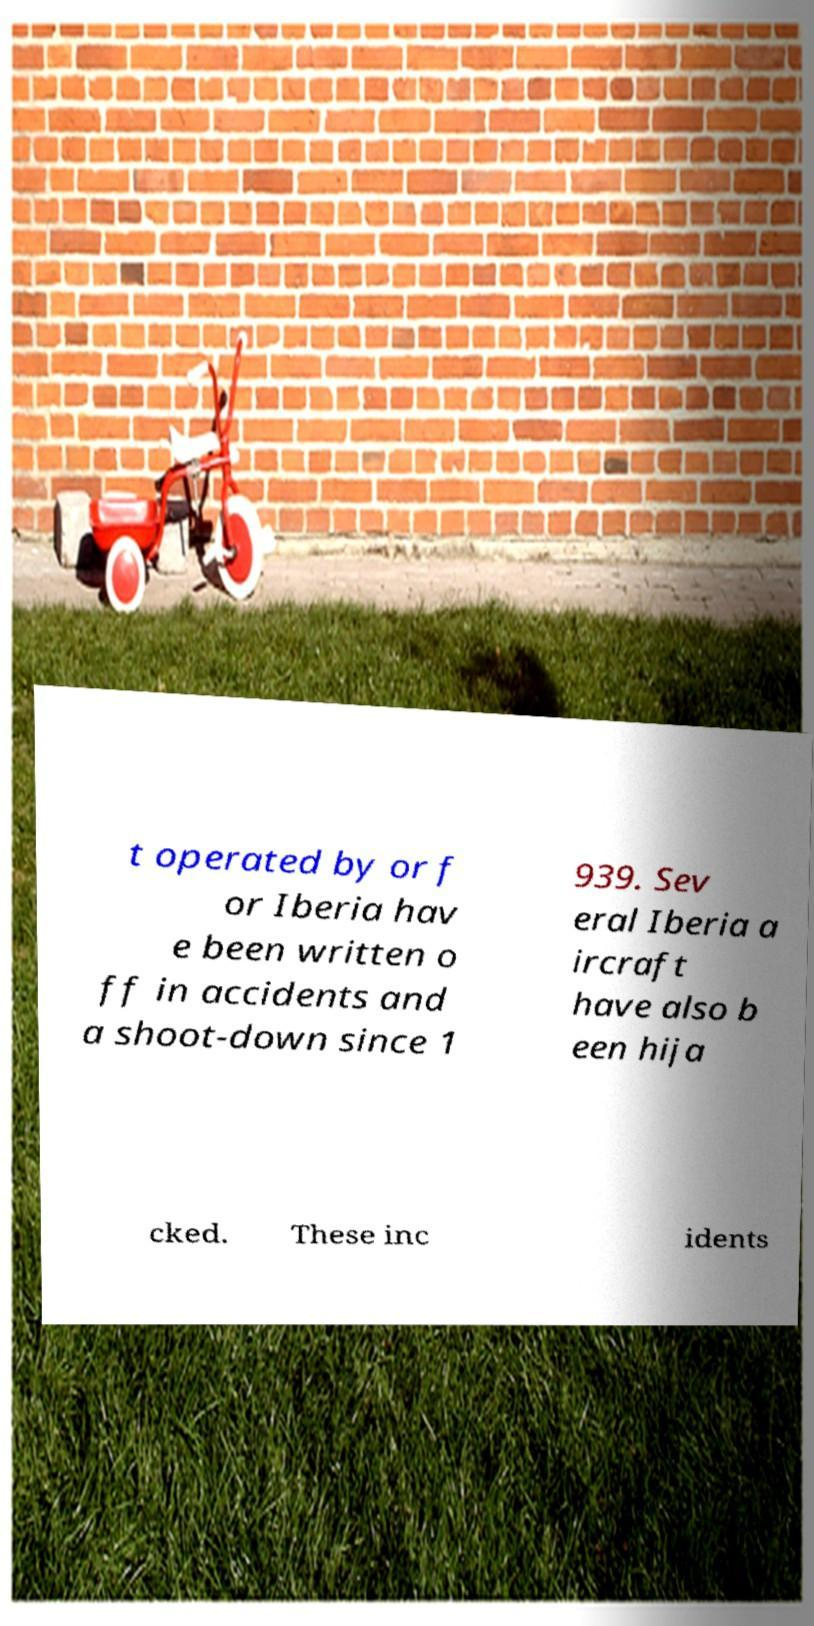For documentation purposes, I need the text within this image transcribed. Could you provide that? t operated by or f or Iberia hav e been written o ff in accidents and a shoot-down since 1 939. Sev eral Iberia a ircraft have also b een hija cked. These inc idents 